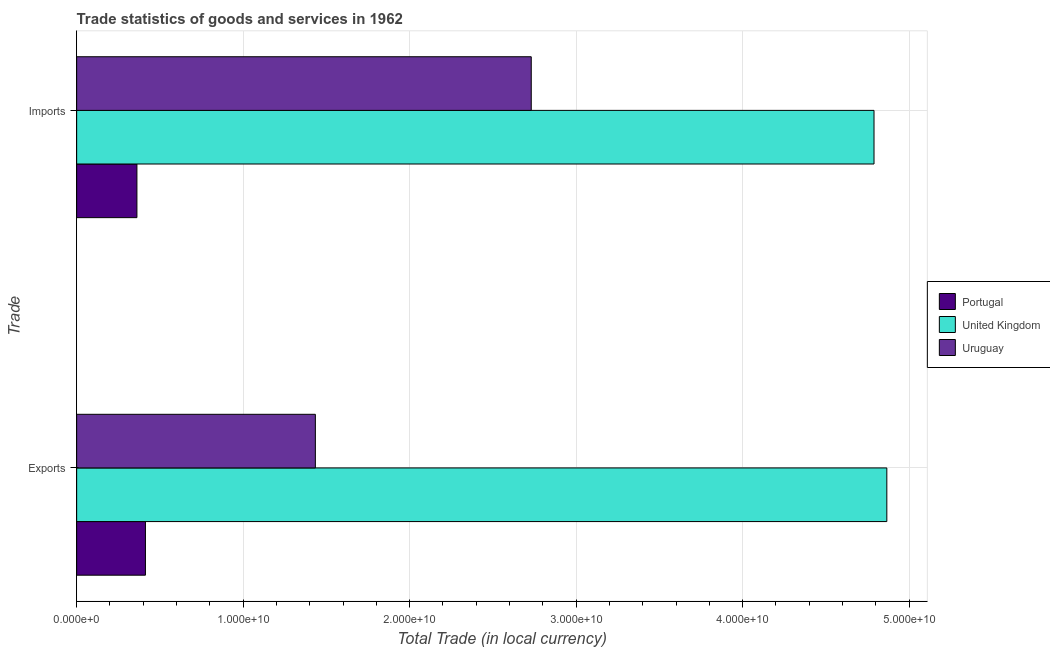How many bars are there on the 2nd tick from the bottom?
Offer a very short reply. 3. What is the label of the 1st group of bars from the top?
Your answer should be compact. Imports. What is the export of goods and services in Uruguay?
Provide a short and direct response. 1.43e+1. Across all countries, what is the maximum export of goods and services?
Offer a very short reply. 4.87e+1. Across all countries, what is the minimum imports of goods and services?
Ensure brevity in your answer.  3.62e+09. In which country was the export of goods and services minimum?
Offer a very short reply. Portugal. What is the total imports of goods and services in the graph?
Make the answer very short. 7.88e+1. What is the difference between the imports of goods and services in Portugal and that in Uruguay?
Your answer should be very brief. -2.37e+1. What is the difference between the export of goods and services in United Kingdom and the imports of goods and services in Portugal?
Provide a short and direct response. 4.50e+1. What is the average export of goods and services per country?
Offer a terse response. 2.24e+1. What is the difference between the export of goods and services and imports of goods and services in Portugal?
Provide a short and direct response. 5.12e+08. What is the ratio of the imports of goods and services in Portugal to that in United Kingdom?
Give a very brief answer. 0.08. In how many countries, is the imports of goods and services greater than the average imports of goods and services taken over all countries?
Make the answer very short. 2. What does the 1st bar from the top in Exports represents?
Your response must be concise. Uruguay. What does the 2nd bar from the bottom in Exports represents?
Your answer should be very brief. United Kingdom. How many bars are there?
Provide a short and direct response. 6. What is the difference between two consecutive major ticks on the X-axis?
Give a very brief answer. 1.00e+1. Where does the legend appear in the graph?
Give a very brief answer. Center right. How many legend labels are there?
Provide a short and direct response. 3. How are the legend labels stacked?
Provide a short and direct response. Vertical. What is the title of the graph?
Offer a very short reply. Trade statistics of goods and services in 1962. Does "Bermuda" appear as one of the legend labels in the graph?
Make the answer very short. No. What is the label or title of the X-axis?
Keep it short and to the point. Total Trade (in local currency). What is the label or title of the Y-axis?
Provide a short and direct response. Trade. What is the Total Trade (in local currency) in Portugal in Exports?
Keep it short and to the point. 4.13e+09. What is the Total Trade (in local currency) in United Kingdom in Exports?
Give a very brief answer. 4.87e+1. What is the Total Trade (in local currency) in Uruguay in Exports?
Your answer should be compact. 1.43e+1. What is the Total Trade (in local currency) of Portugal in Imports?
Provide a succinct answer. 3.62e+09. What is the Total Trade (in local currency) in United Kingdom in Imports?
Provide a succinct answer. 4.79e+1. What is the Total Trade (in local currency) of Uruguay in Imports?
Your response must be concise. 2.73e+1. Across all Trade, what is the maximum Total Trade (in local currency) of Portugal?
Make the answer very short. 4.13e+09. Across all Trade, what is the maximum Total Trade (in local currency) of United Kingdom?
Keep it short and to the point. 4.87e+1. Across all Trade, what is the maximum Total Trade (in local currency) in Uruguay?
Keep it short and to the point. 2.73e+1. Across all Trade, what is the minimum Total Trade (in local currency) in Portugal?
Keep it short and to the point. 3.62e+09. Across all Trade, what is the minimum Total Trade (in local currency) of United Kingdom?
Your answer should be compact. 4.79e+1. Across all Trade, what is the minimum Total Trade (in local currency) in Uruguay?
Provide a short and direct response. 1.43e+1. What is the total Total Trade (in local currency) of Portugal in the graph?
Ensure brevity in your answer.  7.75e+09. What is the total Total Trade (in local currency) of United Kingdom in the graph?
Your response must be concise. 9.66e+1. What is the total Total Trade (in local currency) in Uruguay in the graph?
Give a very brief answer. 4.16e+1. What is the difference between the Total Trade (in local currency) of Portugal in Exports and that in Imports?
Ensure brevity in your answer.  5.12e+08. What is the difference between the Total Trade (in local currency) of United Kingdom in Exports and that in Imports?
Give a very brief answer. 7.69e+08. What is the difference between the Total Trade (in local currency) in Uruguay in Exports and that in Imports?
Your answer should be very brief. -1.30e+1. What is the difference between the Total Trade (in local currency) of Portugal in Exports and the Total Trade (in local currency) of United Kingdom in Imports?
Offer a very short reply. -4.38e+1. What is the difference between the Total Trade (in local currency) of Portugal in Exports and the Total Trade (in local currency) of Uruguay in Imports?
Ensure brevity in your answer.  -2.32e+1. What is the difference between the Total Trade (in local currency) of United Kingdom in Exports and the Total Trade (in local currency) of Uruguay in Imports?
Offer a very short reply. 2.14e+1. What is the average Total Trade (in local currency) in Portugal per Trade?
Offer a very short reply. 3.88e+09. What is the average Total Trade (in local currency) in United Kingdom per Trade?
Your answer should be compact. 4.83e+1. What is the average Total Trade (in local currency) of Uruguay per Trade?
Ensure brevity in your answer.  2.08e+1. What is the difference between the Total Trade (in local currency) in Portugal and Total Trade (in local currency) in United Kingdom in Exports?
Keep it short and to the point. -4.45e+1. What is the difference between the Total Trade (in local currency) of Portugal and Total Trade (in local currency) of Uruguay in Exports?
Your response must be concise. -1.02e+1. What is the difference between the Total Trade (in local currency) in United Kingdom and Total Trade (in local currency) in Uruguay in Exports?
Offer a terse response. 3.43e+1. What is the difference between the Total Trade (in local currency) of Portugal and Total Trade (in local currency) of United Kingdom in Imports?
Offer a very short reply. -4.43e+1. What is the difference between the Total Trade (in local currency) of Portugal and Total Trade (in local currency) of Uruguay in Imports?
Provide a short and direct response. -2.37e+1. What is the difference between the Total Trade (in local currency) in United Kingdom and Total Trade (in local currency) in Uruguay in Imports?
Offer a very short reply. 2.06e+1. What is the ratio of the Total Trade (in local currency) in Portugal in Exports to that in Imports?
Provide a short and direct response. 1.14. What is the ratio of the Total Trade (in local currency) in United Kingdom in Exports to that in Imports?
Offer a terse response. 1.02. What is the ratio of the Total Trade (in local currency) of Uruguay in Exports to that in Imports?
Make the answer very short. 0.53. What is the difference between the highest and the second highest Total Trade (in local currency) of Portugal?
Make the answer very short. 5.12e+08. What is the difference between the highest and the second highest Total Trade (in local currency) of United Kingdom?
Make the answer very short. 7.69e+08. What is the difference between the highest and the second highest Total Trade (in local currency) of Uruguay?
Make the answer very short. 1.30e+1. What is the difference between the highest and the lowest Total Trade (in local currency) in Portugal?
Keep it short and to the point. 5.12e+08. What is the difference between the highest and the lowest Total Trade (in local currency) in United Kingdom?
Your response must be concise. 7.69e+08. What is the difference between the highest and the lowest Total Trade (in local currency) in Uruguay?
Offer a terse response. 1.30e+1. 